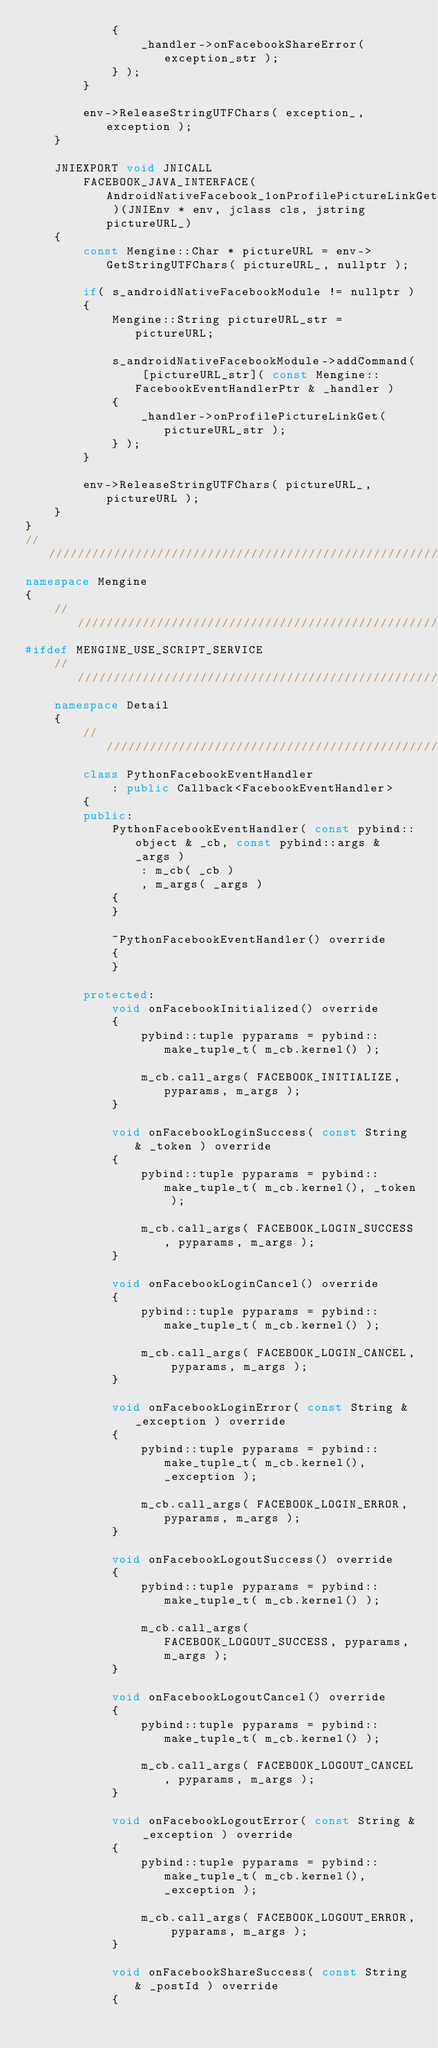<code> <loc_0><loc_0><loc_500><loc_500><_C++_>            {
                _handler->onFacebookShareError( exception_str );
            } );
        }

        env->ReleaseStringUTFChars( exception_, exception );
    }

    JNIEXPORT void JNICALL
        FACEBOOK_JAVA_INTERFACE( AndroidNativeFacebook_1onProfilePictureLinkGet )(JNIEnv * env, jclass cls, jstring pictureURL_)
    {
        const Mengine::Char * pictureURL = env->GetStringUTFChars( pictureURL_, nullptr );

        if( s_androidNativeFacebookModule != nullptr )
        {
            Mengine::String pictureURL_str = pictureURL;

            s_androidNativeFacebookModule->addCommand( [pictureURL_str]( const Mengine::FacebookEventHandlerPtr & _handler )
            {
                _handler->onProfilePictureLinkGet( pictureURL_str );
            } );
        }

        env->ReleaseStringUTFChars( pictureURL_, pictureURL );
    }
}
///////////////////////////////////////////////////////////////////////////////////////////////////////////////////////
namespace Mengine
{
    //////////////////////////////////////////////////////////////////////////
#ifdef MENGINE_USE_SCRIPT_SERVICE
    //////////////////////////////////////////////////////////////////////////
    namespace Detail
    {
        //////////////////////////////////////////////////////////////////////////
        class PythonFacebookEventHandler
            : public Callback<FacebookEventHandler>
        {
        public:
            PythonFacebookEventHandler( const pybind::object & _cb, const pybind::args & _args )
                : m_cb( _cb )
                , m_args( _args )
            {
            }

            ~PythonFacebookEventHandler() override
            {
            }

        protected:
            void onFacebookInitialized() override
            {
                pybind::tuple pyparams = pybind::make_tuple_t( m_cb.kernel() );

                m_cb.call_args( FACEBOOK_INITIALIZE, pyparams, m_args );
            }

            void onFacebookLoginSuccess( const String & _token ) override
            {
                pybind::tuple pyparams = pybind::make_tuple_t( m_cb.kernel(), _token );

                m_cb.call_args( FACEBOOK_LOGIN_SUCCESS, pyparams, m_args );
            }

            void onFacebookLoginCancel() override
            {
                pybind::tuple pyparams = pybind::make_tuple_t( m_cb.kernel() );

                m_cb.call_args( FACEBOOK_LOGIN_CANCEL, pyparams, m_args );
            }

            void onFacebookLoginError( const String & _exception ) override
            {
                pybind::tuple pyparams = pybind::make_tuple_t( m_cb.kernel(), _exception );

                m_cb.call_args( FACEBOOK_LOGIN_ERROR, pyparams, m_args );
            }

            void onFacebookLogoutSuccess() override
            {
                pybind::tuple pyparams = pybind::make_tuple_t( m_cb.kernel() );

                m_cb.call_args( FACEBOOK_LOGOUT_SUCCESS, pyparams, m_args );
            }

            void onFacebookLogoutCancel() override
            {
                pybind::tuple pyparams = pybind::make_tuple_t( m_cb.kernel() );

                m_cb.call_args( FACEBOOK_LOGOUT_CANCEL, pyparams, m_args );
            }

            void onFacebookLogoutError( const String & _exception ) override
            {
                pybind::tuple pyparams = pybind::make_tuple_t( m_cb.kernel(), _exception );

                m_cb.call_args( FACEBOOK_LOGOUT_ERROR, pyparams, m_args );
            }

            void onFacebookShareSuccess( const String & _postId ) override
            {</code> 